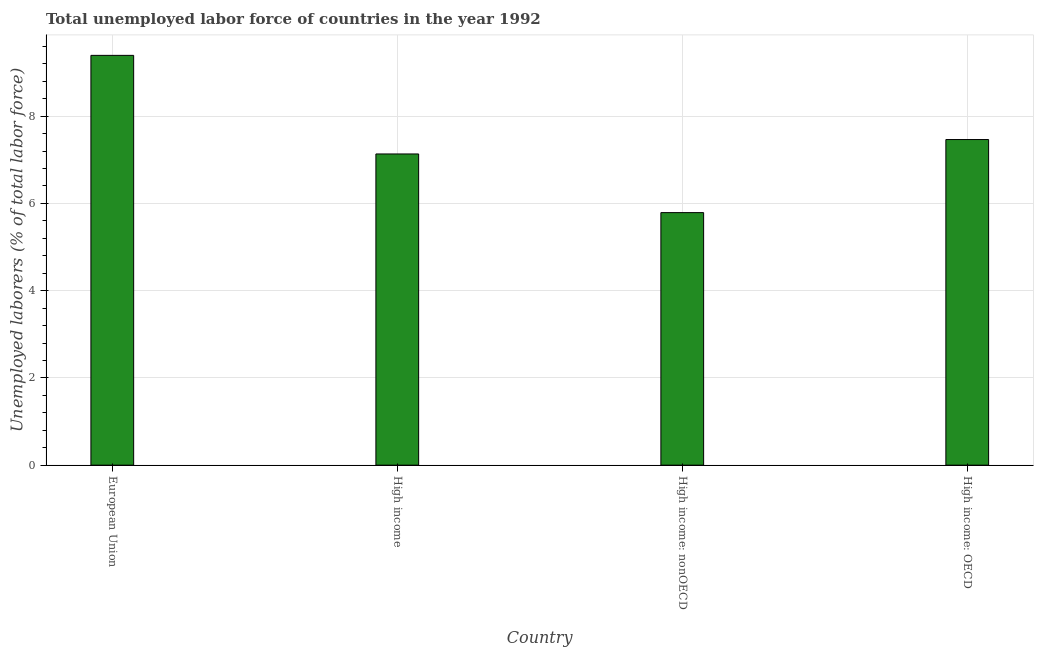What is the title of the graph?
Your answer should be very brief. Total unemployed labor force of countries in the year 1992. What is the label or title of the X-axis?
Keep it short and to the point. Country. What is the label or title of the Y-axis?
Your response must be concise. Unemployed laborers (% of total labor force). What is the total unemployed labour force in European Union?
Offer a very short reply. 9.39. Across all countries, what is the maximum total unemployed labour force?
Keep it short and to the point. 9.39. Across all countries, what is the minimum total unemployed labour force?
Make the answer very short. 5.79. In which country was the total unemployed labour force maximum?
Provide a succinct answer. European Union. In which country was the total unemployed labour force minimum?
Your answer should be compact. High income: nonOECD. What is the sum of the total unemployed labour force?
Your answer should be compact. 29.78. What is the difference between the total unemployed labour force in European Union and High income: nonOECD?
Make the answer very short. 3.6. What is the average total unemployed labour force per country?
Provide a short and direct response. 7.45. What is the median total unemployed labour force?
Make the answer very short. 7.3. In how many countries, is the total unemployed labour force greater than 6.4 %?
Ensure brevity in your answer.  3. What is the ratio of the total unemployed labour force in European Union to that in High income: OECD?
Offer a terse response. 1.26. Is the total unemployed labour force in High income: OECD less than that in High income: nonOECD?
Make the answer very short. No. Is the difference between the total unemployed labour force in European Union and High income greater than the difference between any two countries?
Keep it short and to the point. No. What is the difference between the highest and the second highest total unemployed labour force?
Give a very brief answer. 1.93. In how many countries, is the total unemployed labour force greater than the average total unemployed labour force taken over all countries?
Ensure brevity in your answer.  2. How many bars are there?
Ensure brevity in your answer.  4. How many countries are there in the graph?
Your answer should be very brief. 4. Are the values on the major ticks of Y-axis written in scientific E-notation?
Your answer should be compact. No. What is the Unemployed laborers (% of total labor force) in European Union?
Your response must be concise. 9.39. What is the Unemployed laborers (% of total labor force) in High income?
Keep it short and to the point. 7.13. What is the Unemployed laborers (% of total labor force) in High income: nonOECD?
Ensure brevity in your answer.  5.79. What is the Unemployed laborers (% of total labor force) of High income: OECD?
Ensure brevity in your answer.  7.46. What is the difference between the Unemployed laborers (% of total labor force) in European Union and High income?
Offer a terse response. 2.26. What is the difference between the Unemployed laborers (% of total labor force) in European Union and High income: nonOECD?
Offer a terse response. 3.6. What is the difference between the Unemployed laborers (% of total labor force) in European Union and High income: OECD?
Your answer should be compact. 1.93. What is the difference between the Unemployed laborers (% of total labor force) in High income and High income: nonOECD?
Your response must be concise. 1.34. What is the difference between the Unemployed laborers (% of total labor force) in High income and High income: OECD?
Keep it short and to the point. -0.33. What is the difference between the Unemployed laborers (% of total labor force) in High income: nonOECD and High income: OECD?
Provide a succinct answer. -1.68. What is the ratio of the Unemployed laborers (% of total labor force) in European Union to that in High income?
Your response must be concise. 1.32. What is the ratio of the Unemployed laborers (% of total labor force) in European Union to that in High income: nonOECD?
Your answer should be compact. 1.62. What is the ratio of the Unemployed laborers (% of total labor force) in European Union to that in High income: OECD?
Keep it short and to the point. 1.26. What is the ratio of the Unemployed laborers (% of total labor force) in High income to that in High income: nonOECD?
Provide a short and direct response. 1.23. What is the ratio of the Unemployed laborers (% of total labor force) in High income to that in High income: OECD?
Keep it short and to the point. 0.96. What is the ratio of the Unemployed laborers (% of total labor force) in High income: nonOECD to that in High income: OECD?
Offer a terse response. 0.78. 